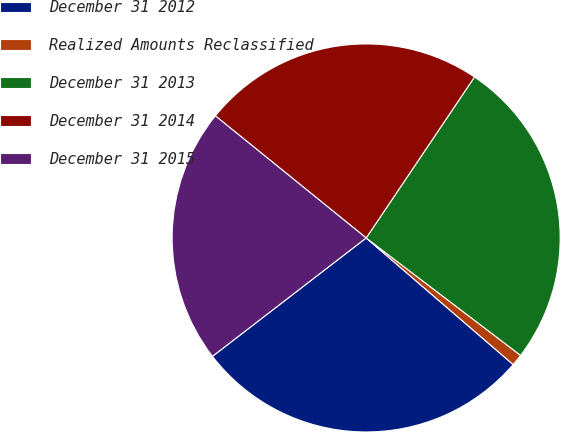Convert chart. <chart><loc_0><loc_0><loc_500><loc_500><pie_chart><fcel>December 31 2012<fcel>Realized Amounts Reclassified<fcel>December 31 2013<fcel>December 31 2014<fcel>December 31 2015<nl><fcel>28.24%<fcel>0.97%<fcel>25.92%<fcel>23.6%<fcel>21.28%<nl></chart> 